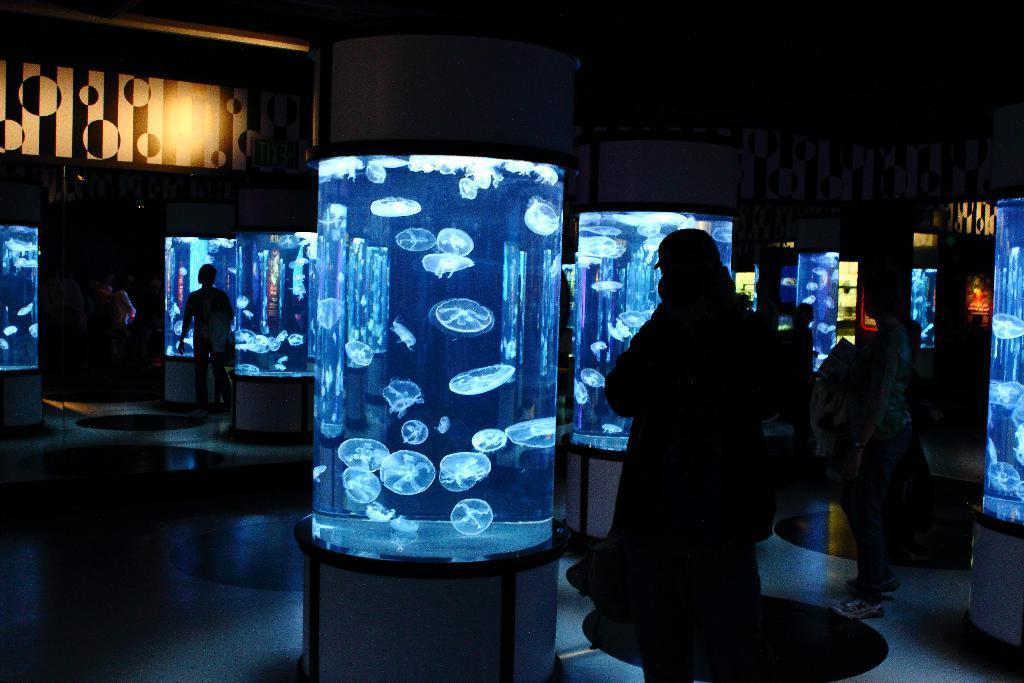How would you summarize this image in a sentence or two? In this picture there are people and aquariums. In the aquariums there are jellyfish. On the left there is a board. In the center of the background there are posters. 